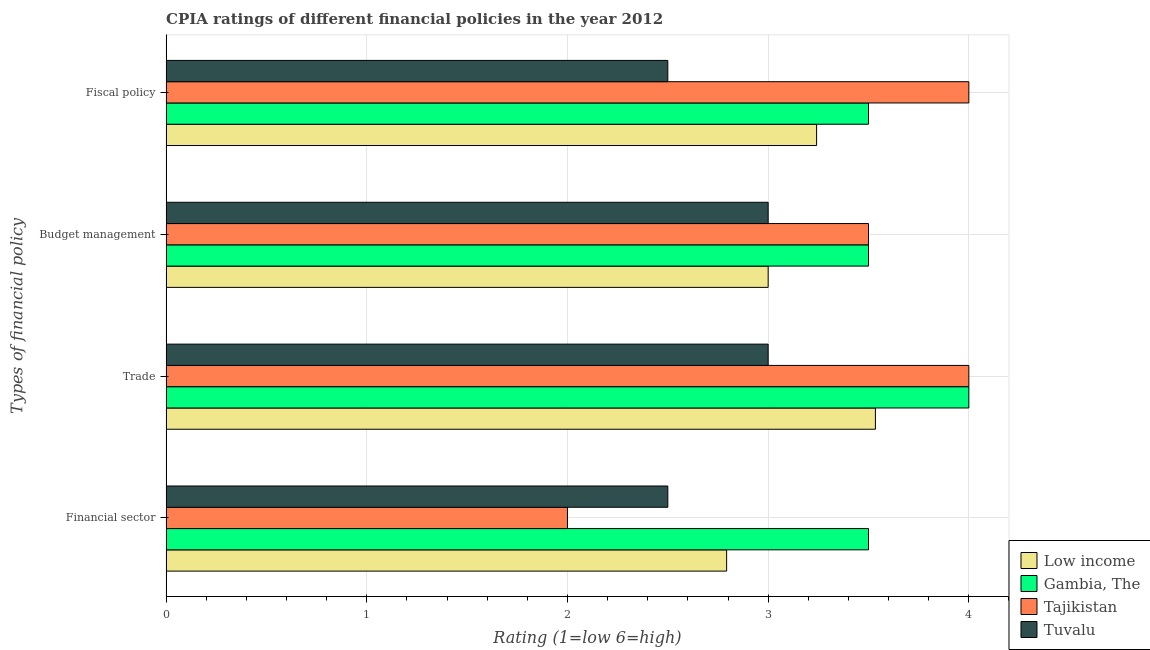How many groups of bars are there?
Give a very brief answer. 4. Are the number of bars per tick equal to the number of legend labels?
Your answer should be compact. Yes. How many bars are there on the 2nd tick from the bottom?
Your answer should be compact. 4. What is the label of the 3rd group of bars from the top?
Provide a short and direct response. Trade. What is the cpia rating of trade in Low income?
Provide a succinct answer. 3.53. Across all countries, what is the minimum cpia rating of fiscal policy?
Provide a succinct answer. 2.5. In which country was the cpia rating of budget management maximum?
Ensure brevity in your answer.  Gambia, The. In which country was the cpia rating of trade minimum?
Your answer should be very brief. Tuvalu. What is the total cpia rating of trade in the graph?
Keep it short and to the point. 14.53. What is the difference between the cpia rating of trade in Tajikistan and that in Tuvalu?
Offer a very short reply. 1. What is the difference between the cpia rating of trade in Tajikistan and the cpia rating of budget management in Low income?
Give a very brief answer. 1. What is the average cpia rating of financial sector per country?
Your answer should be compact. 2.7. What is the difference between the cpia rating of financial sector and cpia rating of budget management in Tuvalu?
Your answer should be very brief. -0.5. What is the ratio of the cpia rating of trade in Low income to that in Gambia, The?
Give a very brief answer. 0.88. Is the cpia rating of financial sector in Tajikistan less than that in Low income?
Offer a very short reply. Yes. Is the difference between the cpia rating of financial sector in Low income and Tajikistan greater than the difference between the cpia rating of trade in Low income and Tajikistan?
Your answer should be compact. Yes. What is the difference between the highest and the lowest cpia rating of financial sector?
Ensure brevity in your answer.  1.5. In how many countries, is the cpia rating of fiscal policy greater than the average cpia rating of fiscal policy taken over all countries?
Your answer should be very brief. 2. Is the sum of the cpia rating of fiscal policy in Low income and Tajikistan greater than the maximum cpia rating of budget management across all countries?
Offer a terse response. Yes. What does the 4th bar from the top in Trade represents?
Provide a succinct answer. Low income. Does the graph contain any zero values?
Offer a very short reply. No. Does the graph contain grids?
Offer a terse response. Yes. Where does the legend appear in the graph?
Keep it short and to the point. Bottom right. What is the title of the graph?
Offer a very short reply. CPIA ratings of different financial policies in the year 2012. What is the label or title of the X-axis?
Offer a very short reply. Rating (1=low 6=high). What is the label or title of the Y-axis?
Your answer should be very brief. Types of financial policy. What is the Rating (1=low 6=high) in Low income in Financial sector?
Provide a short and direct response. 2.79. What is the Rating (1=low 6=high) in Gambia, The in Financial sector?
Offer a terse response. 3.5. What is the Rating (1=low 6=high) in Tuvalu in Financial sector?
Keep it short and to the point. 2.5. What is the Rating (1=low 6=high) in Low income in Trade?
Keep it short and to the point. 3.53. What is the Rating (1=low 6=high) of Gambia, The in Trade?
Your answer should be very brief. 4. What is the Rating (1=low 6=high) in Low income in Budget management?
Keep it short and to the point. 3. What is the Rating (1=low 6=high) of Gambia, The in Budget management?
Make the answer very short. 3.5. What is the Rating (1=low 6=high) in Tajikistan in Budget management?
Your answer should be compact. 3.5. What is the Rating (1=low 6=high) of Tuvalu in Budget management?
Make the answer very short. 3. What is the Rating (1=low 6=high) of Low income in Fiscal policy?
Provide a short and direct response. 3.24. Across all Types of financial policy, what is the maximum Rating (1=low 6=high) in Low income?
Keep it short and to the point. 3.53. Across all Types of financial policy, what is the maximum Rating (1=low 6=high) of Tajikistan?
Your answer should be compact. 4. Across all Types of financial policy, what is the minimum Rating (1=low 6=high) in Low income?
Give a very brief answer. 2.79. Across all Types of financial policy, what is the minimum Rating (1=low 6=high) in Tajikistan?
Ensure brevity in your answer.  2. Across all Types of financial policy, what is the minimum Rating (1=low 6=high) in Tuvalu?
Provide a succinct answer. 2.5. What is the total Rating (1=low 6=high) in Low income in the graph?
Ensure brevity in your answer.  12.57. What is the total Rating (1=low 6=high) in Tajikistan in the graph?
Provide a short and direct response. 13.5. What is the total Rating (1=low 6=high) of Tuvalu in the graph?
Offer a very short reply. 11. What is the difference between the Rating (1=low 6=high) of Low income in Financial sector and that in Trade?
Offer a very short reply. -0.74. What is the difference between the Rating (1=low 6=high) of Low income in Financial sector and that in Budget management?
Your answer should be very brief. -0.21. What is the difference between the Rating (1=low 6=high) of Tajikistan in Financial sector and that in Budget management?
Your response must be concise. -1.5. What is the difference between the Rating (1=low 6=high) in Low income in Financial sector and that in Fiscal policy?
Ensure brevity in your answer.  -0.45. What is the difference between the Rating (1=low 6=high) of Low income in Trade and that in Budget management?
Offer a very short reply. 0.53. What is the difference between the Rating (1=low 6=high) of Low income in Trade and that in Fiscal policy?
Your response must be concise. 0.29. What is the difference between the Rating (1=low 6=high) in Gambia, The in Trade and that in Fiscal policy?
Your answer should be compact. 0.5. What is the difference between the Rating (1=low 6=high) of Tajikistan in Trade and that in Fiscal policy?
Offer a very short reply. 0. What is the difference between the Rating (1=low 6=high) of Low income in Budget management and that in Fiscal policy?
Give a very brief answer. -0.24. What is the difference between the Rating (1=low 6=high) in Gambia, The in Budget management and that in Fiscal policy?
Keep it short and to the point. 0. What is the difference between the Rating (1=low 6=high) in Tuvalu in Budget management and that in Fiscal policy?
Offer a very short reply. 0.5. What is the difference between the Rating (1=low 6=high) in Low income in Financial sector and the Rating (1=low 6=high) in Gambia, The in Trade?
Ensure brevity in your answer.  -1.21. What is the difference between the Rating (1=low 6=high) of Low income in Financial sector and the Rating (1=low 6=high) of Tajikistan in Trade?
Provide a succinct answer. -1.21. What is the difference between the Rating (1=low 6=high) of Low income in Financial sector and the Rating (1=low 6=high) of Tuvalu in Trade?
Give a very brief answer. -0.21. What is the difference between the Rating (1=low 6=high) of Gambia, The in Financial sector and the Rating (1=low 6=high) of Tajikistan in Trade?
Offer a very short reply. -0.5. What is the difference between the Rating (1=low 6=high) of Gambia, The in Financial sector and the Rating (1=low 6=high) of Tuvalu in Trade?
Ensure brevity in your answer.  0.5. What is the difference between the Rating (1=low 6=high) in Tajikistan in Financial sector and the Rating (1=low 6=high) in Tuvalu in Trade?
Your answer should be very brief. -1. What is the difference between the Rating (1=low 6=high) in Low income in Financial sector and the Rating (1=low 6=high) in Gambia, The in Budget management?
Give a very brief answer. -0.71. What is the difference between the Rating (1=low 6=high) of Low income in Financial sector and the Rating (1=low 6=high) of Tajikistan in Budget management?
Offer a very short reply. -0.71. What is the difference between the Rating (1=low 6=high) of Low income in Financial sector and the Rating (1=low 6=high) of Tuvalu in Budget management?
Ensure brevity in your answer.  -0.21. What is the difference between the Rating (1=low 6=high) of Gambia, The in Financial sector and the Rating (1=low 6=high) of Tajikistan in Budget management?
Offer a very short reply. 0. What is the difference between the Rating (1=low 6=high) in Low income in Financial sector and the Rating (1=low 6=high) in Gambia, The in Fiscal policy?
Your response must be concise. -0.71. What is the difference between the Rating (1=low 6=high) of Low income in Financial sector and the Rating (1=low 6=high) of Tajikistan in Fiscal policy?
Give a very brief answer. -1.21. What is the difference between the Rating (1=low 6=high) of Low income in Financial sector and the Rating (1=low 6=high) of Tuvalu in Fiscal policy?
Keep it short and to the point. 0.29. What is the difference between the Rating (1=low 6=high) in Gambia, The in Financial sector and the Rating (1=low 6=high) in Tajikistan in Fiscal policy?
Give a very brief answer. -0.5. What is the difference between the Rating (1=low 6=high) of Tajikistan in Financial sector and the Rating (1=low 6=high) of Tuvalu in Fiscal policy?
Give a very brief answer. -0.5. What is the difference between the Rating (1=low 6=high) in Low income in Trade and the Rating (1=low 6=high) in Gambia, The in Budget management?
Your answer should be compact. 0.03. What is the difference between the Rating (1=low 6=high) of Low income in Trade and the Rating (1=low 6=high) of Tajikistan in Budget management?
Your answer should be compact. 0.03. What is the difference between the Rating (1=low 6=high) in Low income in Trade and the Rating (1=low 6=high) in Tuvalu in Budget management?
Ensure brevity in your answer.  0.53. What is the difference between the Rating (1=low 6=high) of Gambia, The in Trade and the Rating (1=low 6=high) of Tajikistan in Budget management?
Keep it short and to the point. 0.5. What is the difference between the Rating (1=low 6=high) of Low income in Trade and the Rating (1=low 6=high) of Gambia, The in Fiscal policy?
Your response must be concise. 0.03. What is the difference between the Rating (1=low 6=high) of Low income in Trade and the Rating (1=low 6=high) of Tajikistan in Fiscal policy?
Your response must be concise. -0.47. What is the difference between the Rating (1=low 6=high) of Low income in Trade and the Rating (1=low 6=high) of Tuvalu in Fiscal policy?
Keep it short and to the point. 1.03. What is the difference between the Rating (1=low 6=high) in Tajikistan in Trade and the Rating (1=low 6=high) in Tuvalu in Fiscal policy?
Ensure brevity in your answer.  1.5. What is the difference between the Rating (1=low 6=high) in Low income in Budget management and the Rating (1=low 6=high) in Tajikistan in Fiscal policy?
Keep it short and to the point. -1. What is the difference between the Rating (1=low 6=high) in Gambia, The in Budget management and the Rating (1=low 6=high) in Tajikistan in Fiscal policy?
Your response must be concise. -0.5. What is the difference between the Rating (1=low 6=high) in Gambia, The in Budget management and the Rating (1=low 6=high) in Tuvalu in Fiscal policy?
Your answer should be very brief. 1. What is the average Rating (1=low 6=high) in Low income per Types of financial policy?
Offer a very short reply. 3.14. What is the average Rating (1=low 6=high) of Gambia, The per Types of financial policy?
Keep it short and to the point. 3.62. What is the average Rating (1=low 6=high) in Tajikistan per Types of financial policy?
Keep it short and to the point. 3.38. What is the average Rating (1=low 6=high) of Tuvalu per Types of financial policy?
Provide a short and direct response. 2.75. What is the difference between the Rating (1=low 6=high) in Low income and Rating (1=low 6=high) in Gambia, The in Financial sector?
Offer a very short reply. -0.71. What is the difference between the Rating (1=low 6=high) in Low income and Rating (1=low 6=high) in Tajikistan in Financial sector?
Ensure brevity in your answer.  0.79. What is the difference between the Rating (1=low 6=high) in Low income and Rating (1=low 6=high) in Tuvalu in Financial sector?
Offer a very short reply. 0.29. What is the difference between the Rating (1=low 6=high) in Gambia, The and Rating (1=low 6=high) in Tuvalu in Financial sector?
Give a very brief answer. 1. What is the difference between the Rating (1=low 6=high) of Tajikistan and Rating (1=low 6=high) of Tuvalu in Financial sector?
Your answer should be very brief. -0.5. What is the difference between the Rating (1=low 6=high) in Low income and Rating (1=low 6=high) in Gambia, The in Trade?
Your response must be concise. -0.47. What is the difference between the Rating (1=low 6=high) in Low income and Rating (1=low 6=high) in Tajikistan in Trade?
Keep it short and to the point. -0.47. What is the difference between the Rating (1=low 6=high) in Low income and Rating (1=low 6=high) in Tuvalu in Trade?
Provide a short and direct response. 0.53. What is the difference between the Rating (1=low 6=high) of Gambia, The and Rating (1=low 6=high) of Tajikistan in Trade?
Your answer should be compact. 0. What is the difference between the Rating (1=low 6=high) in Low income and Rating (1=low 6=high) in Gambia, The in Budget management?
Offer a very short reply. -0.5. What is the difference between the Rating (1=low 6=high) of Low income and Rating (1=low 6=high) of Tuvalu in Budget management?
Provide a succinct answer. 0. What is the difference between the Rating (1=low 6=high) of Low income and Rating (1=low 6=high) of Gambia, The in Fiscal policy?
Your answer should be compact. -0.26. What is the difference between the Rating (1=low 6=high) in Low income and Rating (1=low 6=high) in Tajikistan in Fiscal policy?
Your answer should be very brief. -0.76. What is the difference between the Rating (1=low 6=high) in Low income and Rating (1=low 6=high) in Tuvalu in Fiscal policy?
Provide a succinct answer. 0.74. What is the difference between the Rating (1=low 6=high) in Gambia, The and Rating (1=low 6=high) in Tajikistan in Fiscal policy?
Your response must be concise. -0.5. What is the difference between the Rating (1=low 6=high) in Tajikistan and Rating (1=low 6=high) in Tuvalu in Fiscal policy?
Provide a succinct answer. 1.5. What is the ratio of the Rating (1=low 6=high) in Low income in Financial sector to that in Trade?
Your response must be concise. 0.79. What is the ratio of the Rating (1=low 6=high) in Gambia, The in Financial sector to that in Trade?
Provide a succinct answer. 0.88. What is the ratio of the Rating (1=low 6=high) in Tuvalu in Financial sector to that in Trade?
Provide a short and direct response. 0.83. What is the ratio of the Rating (1=low 6=high) of Tuvalu in Financial sector to that in Budget management?
Offer a terse response. 0.83. What is the ratio of the Rating (1=low 6=high) of Low income in Financial sector to that in Fiscal policy?
Give a very brief answer. 0.86. What is the ratio of the Rating (1=low 6=high) in Gambia, The in Financial sector to that in Fiscal policy?
Your answer should be very brief. 1. What is the ratio of the Rating (1=low 6=high) of Tuvalu in Financial sector to that in Fiscal policy?
Offer a terse response. 1. What is the ratio of the Rating (1=low 6=high) in Low income in Trade to that in Budget management?
Keep it short and to the point. 1.18. What is the ratio of the Rating (1=low 6=high) in Gambia, The in Trade to that in Budget management?
Provide a succinct answer. 1.14. What is the ratio of the Rating (1=low 6=high) of Tajikistan in Trade to that in Budget management?
Provide a succinct answer. 1.14. What is the ratio of the Rating (1=low 6=high) in Tuvalu in Trade to that in Budget management?
Offer a terse response. 1. What is the ratio of the Rating (1=low 6=high) of Low income in Trade to that in Fiscal policy?
Offer a very short reply. 1.09. What is the ratio of the Rating (1=low 6=high) of Gambia, The in Trade to that in Fiscal policy?
Make the answer very short. 1.14. What is the ratio of the Rating (1=low 6=high) of Tajikistan in Trade to that in Fiscal policy?
Ensure brevity in your answer.  1. What is the ratio of the Rating (1=low 6=high) of Tuvalu in Trade to that in Fiscal policy?
Ensure brevity in your answer.  1.2. What is the ratio of the Rating (1=low 6=high) in Low income in Budget management to that in Fiscal policy?
Your answer should be compact. 0.93. What is the ratio of the Rating (1=low 6=high) of Gambia, The in Budget management to that in Fiscal policy?
Provide a succinct answer. 1. What is the ratio of the Rating (1=low 6=high) of Tuvalu in Budget management to that in Fiscal policy?
Offer a terse response. 1.2. What is the difference between the highest and the second highest Rating (1=low 6=high) of Low income?
Provide a succinct answer. 0.29. What is the difference between the highest and the second highest Rating (1=low 6=high) in Tajikistan?
Offer a very short reply. 0. What is the difference between the highest and the second highest Rating (1=low 6=high) of Tuvalu?
Make the answer very short. 0. What is the difference between the highest and the lowest Rating (1=low 6=high) in Low income?
Offer a terse response. 0.74. What is the difference between the highest and the lowest Rating (1=low 6=high) of Tajikistan?
Ensure brevity in your answer.  2. What is the difference between the highest and the lowest Rating (1=low 6=high) of Tuvalu?
Provide a succinct answer. 0.5. 